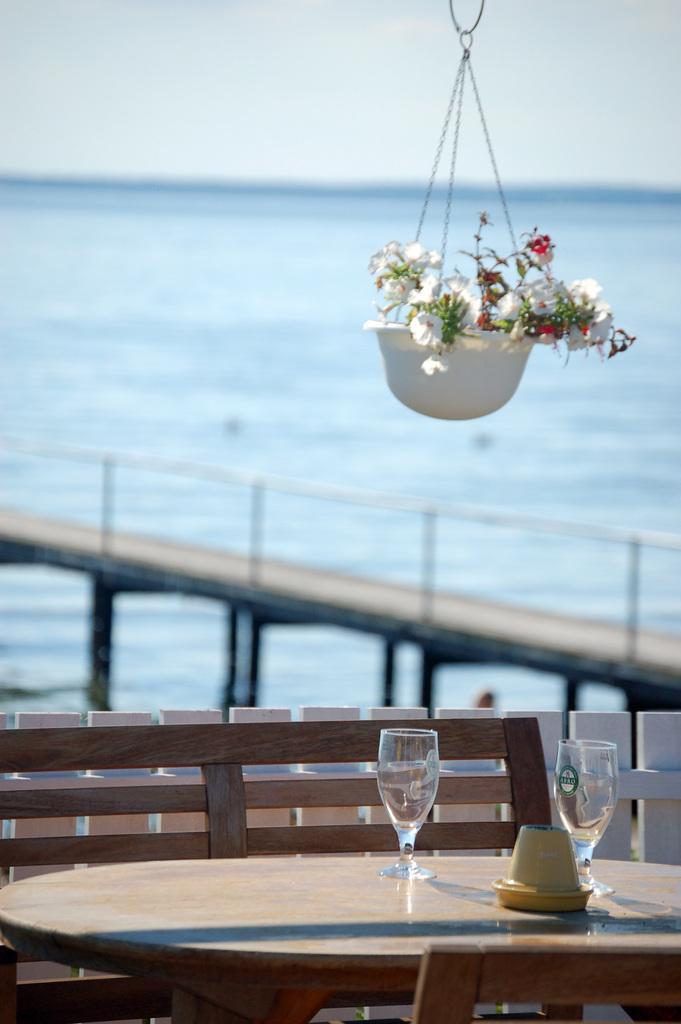Can you describe this image briefly? In this picture we can see a flower pot hanging on the top of the dining table with two glass of water and wooden chair in front. Behind there is a bridge and sea side view which is beautiful. 